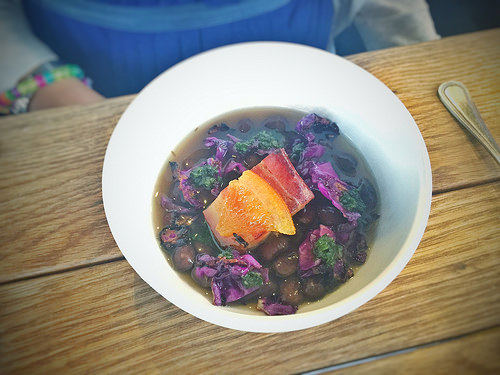<image>
Is there a leaf on the soup? Yes. Looking at the image, I can see the leaf is positioned on top of the soup, with the soup providing support. 